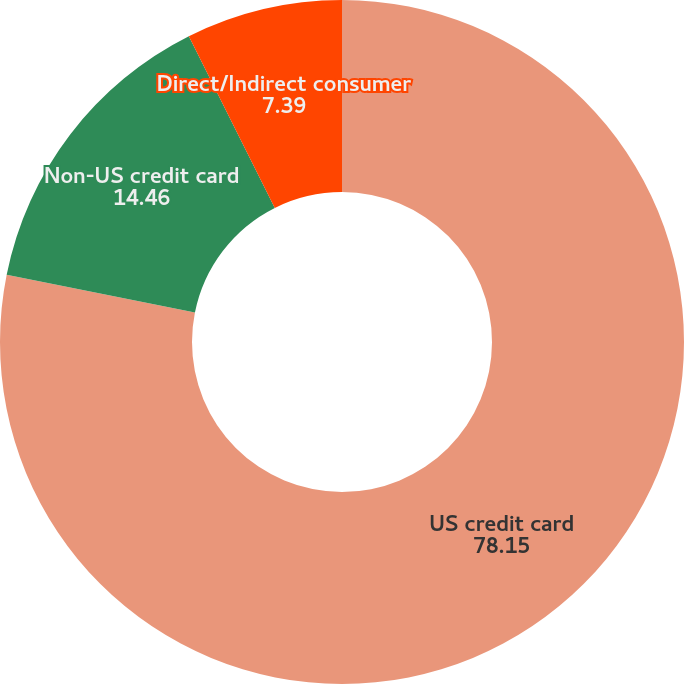<chart> <loc_0><loc_0><loc_500><loc_500><pie_chart><fcel>US credit card<fcel>Non-US credit card<fcel>Direct/Indirect consumer<nl><fcel>78.15%<fcel>14.46%<fcel>7.39%<nl></chart> 